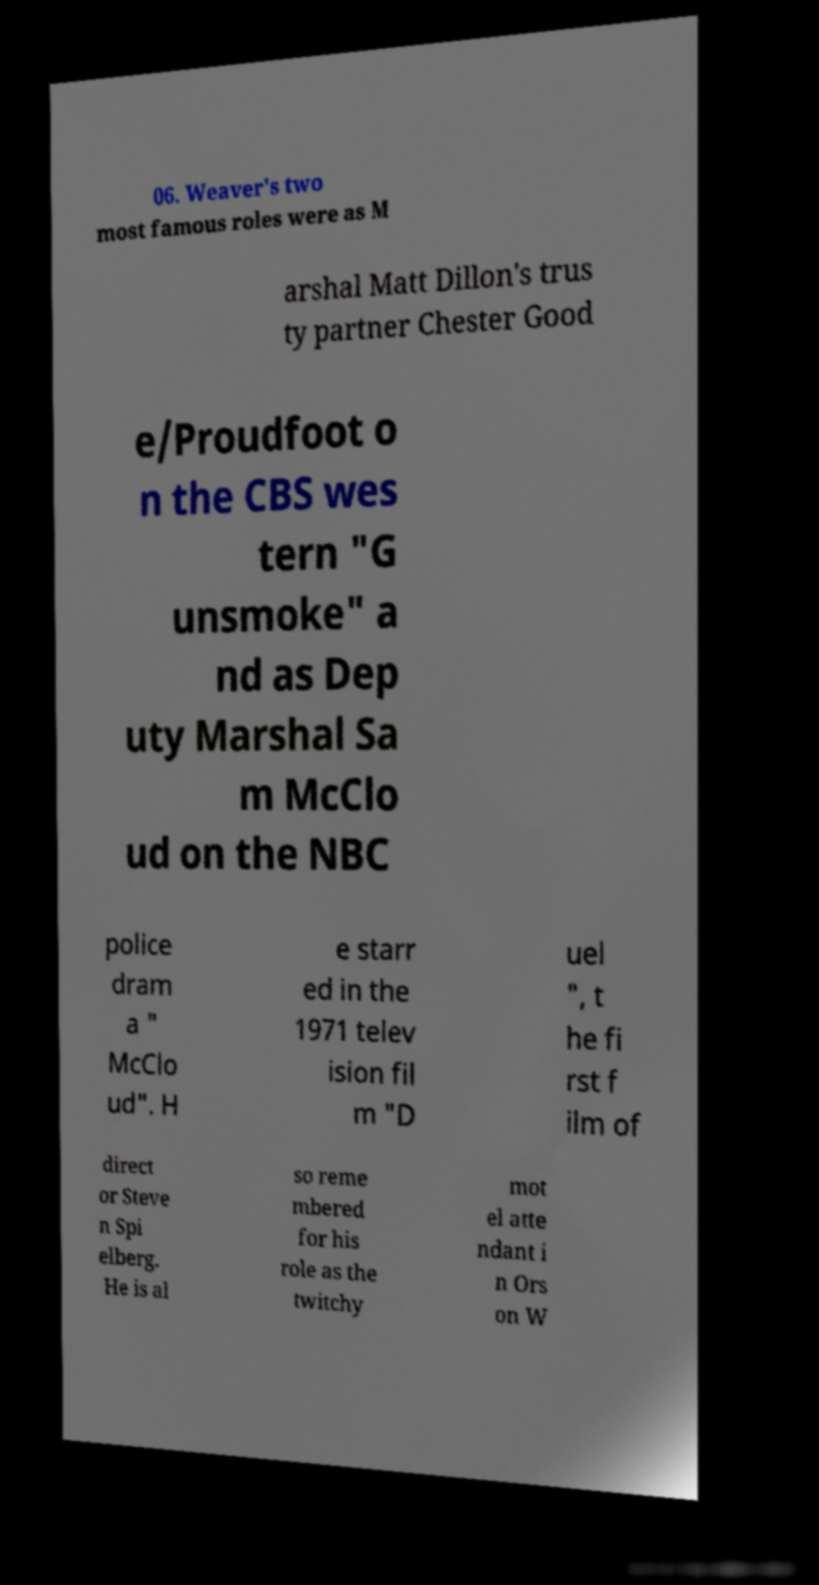Can you read and provide the text displayed in the image?This photo seems to have some interesting text. Can you extract and type it out for me? 06. Weaver's two most famous roles were as M arshal Matt Dillon's trus ty partner Chester Good e/Proudfoot o n the CBS wes tern "G unsmoke" a nd as Dep uty Marshal Sa m McClo ud on the NBC police dram a " McClo ud". H e starr ed in the 1971 telev ision fil m "D uel ", t he fi rst f ilm of direct or Steve n Spi elberg. He is al so reme mbered for his role as the twitchy mot el atte ndant i n Ors on W 